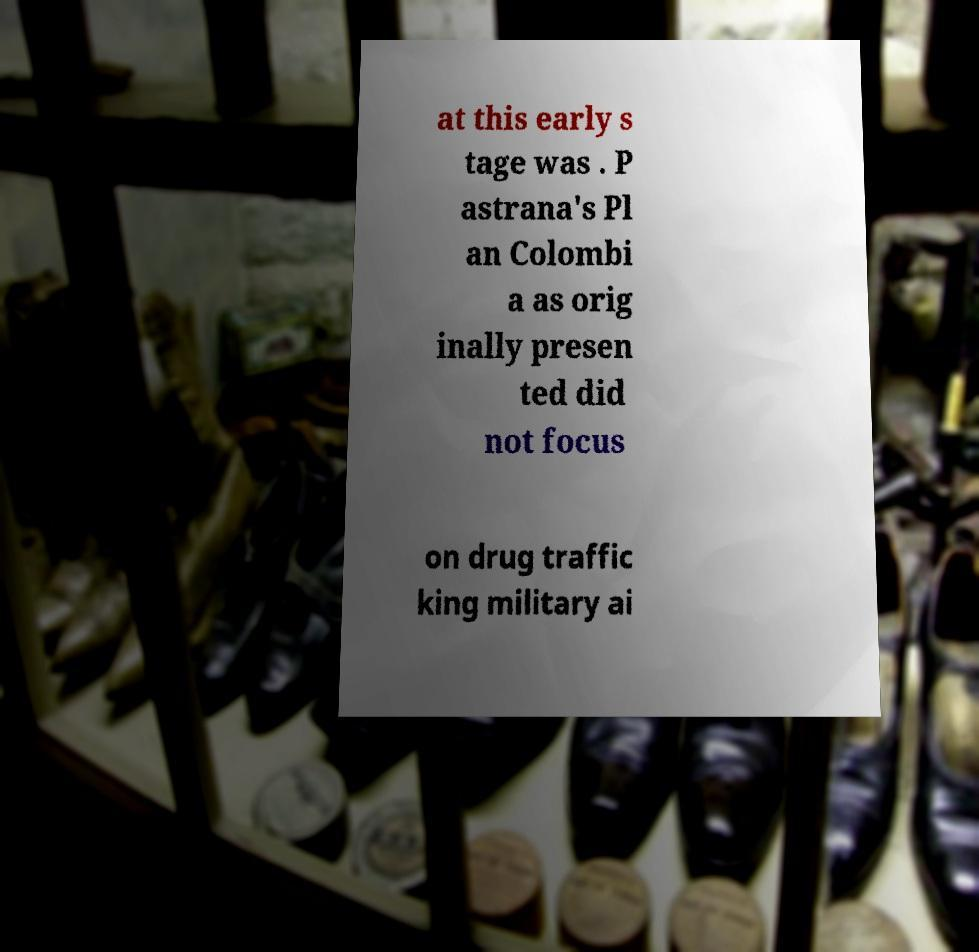Could you extract and type out the text from this image? at this early s tage was . P astrana's Pl an Colombi a as orig inally presen ted did not focus on drug traffic king military ai 